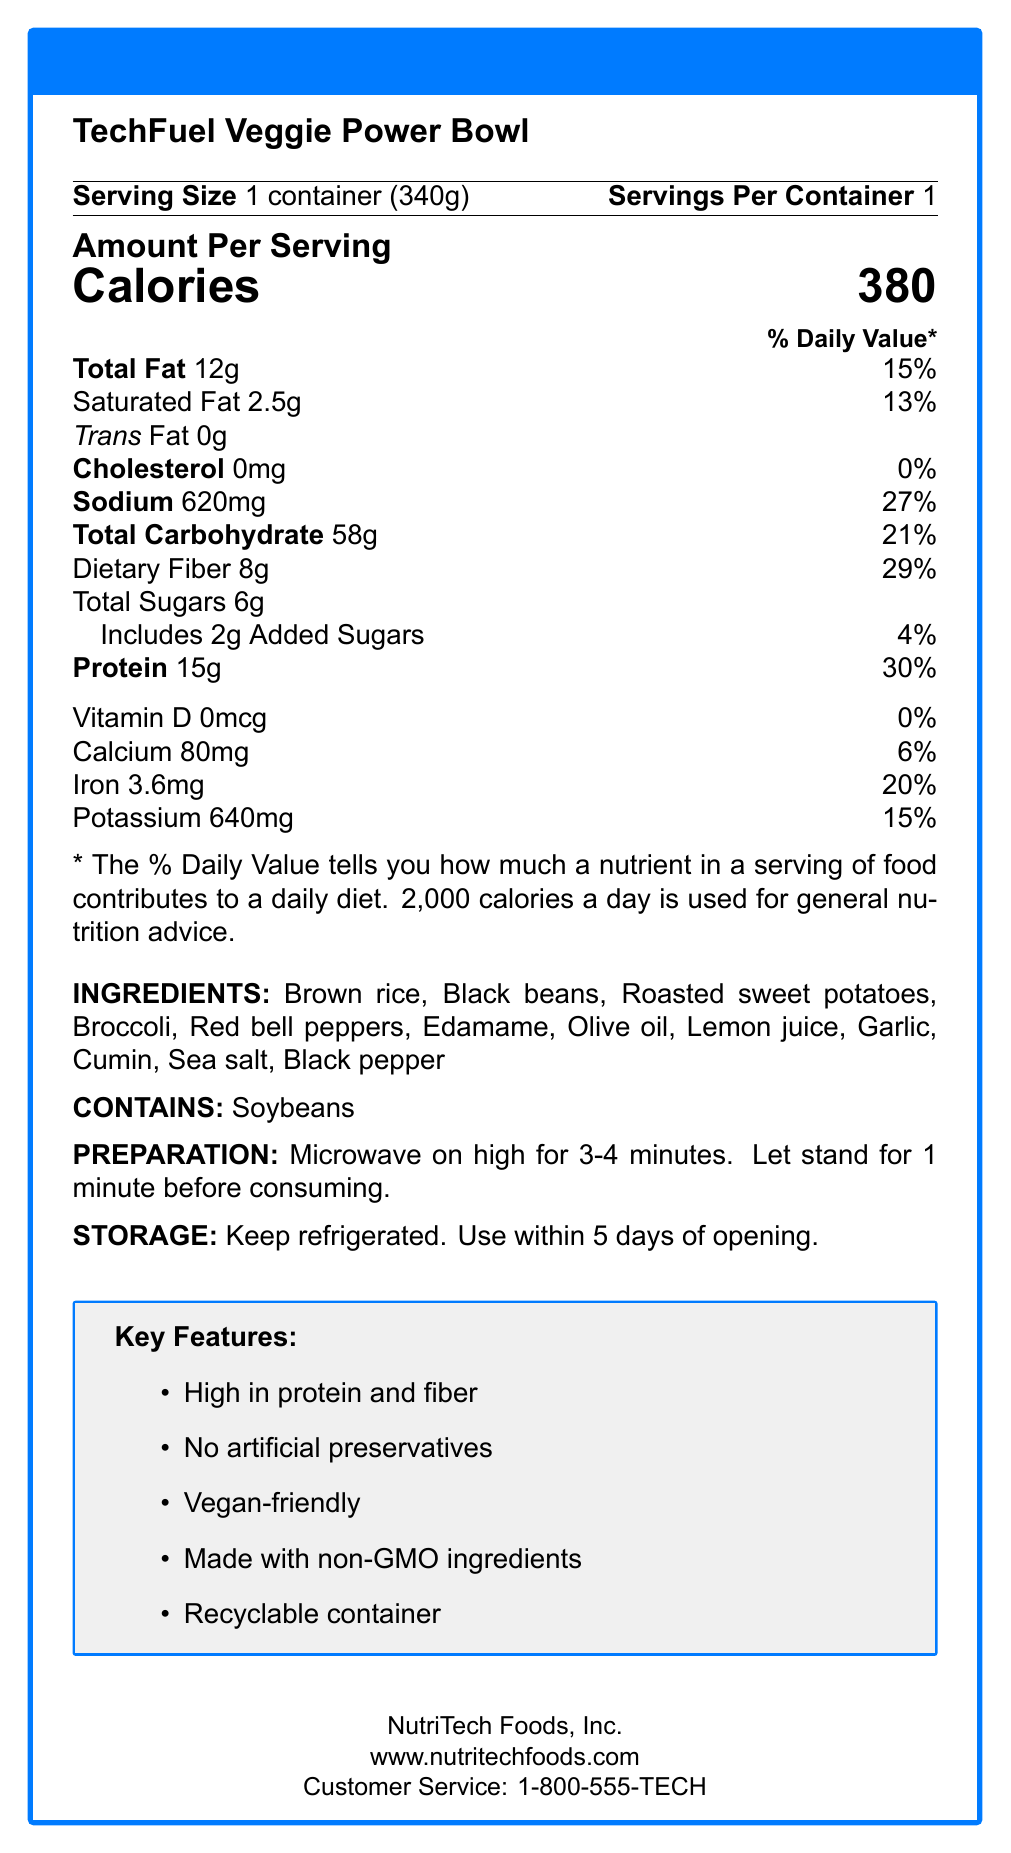what is the serving size of the TechFuel Veggie Power Bowl? The serving size is clearly stated as "1 container (340g)" near the top of the document.
Answer: 1 container (340g) how many calories are in one serving of the TechFuel Veggie Power Bowl? The calorie count for one serving is listed as 380 in the "Amount Per Serving" section.
Answer: 380 what are the main ingredients in the TechFuel Veggie Power Bowl? The ingredients are listed after the nutrition facts section under "INGREDIENTS."
Answer: Brown rice, Black beans, Roasted sweet potatoes, Broccoli, Red bell peppers, Edamame, Olive oil, Lemon juice, Garlic, Cumin, Sea salt, Black pepper how much sodium is in one serving, and what percentage of the daily value does it represent? The label shows that there is 620mg of sodium, which is 27% of the daily value.
Answer: 620mg, 27% what is the recommended preparation method for the TechFuel Veggie Power Bowl? The preparation instructions are listed under "PREPARATION."
Answer: Microwave on high for 3-4 minutes. Let stand for 1 minute before consuming. which nutrient has the highest daily value percentage in the TechFuel Veggie Power Bowl? The protein content has the highest daily value percentage of 30%, as shown in the nutrition facts.
Answer: Protein, 30% which of the following is NOT listed as a feature of the TechFuel Veggie Power Bowl? A. High in protein and fiber B. Contains artificial preservatives C. Vegan-friendly D. Made with non-GMO ingredients E. Recyclable container The nutrition label states that there are no artificial preservatives, making B the correct answer.
Answer: B what is the total carbohydrate content in one serving, and what is its percentage of the daily value? The total carbohydrate content is 58g and represents 21% of the daily value.
Answer: 58g, 21% what company manufactures the TechFuel Veggie Power Bowl? The manufacturer information at the bottom of the document states that NutriTech Foods, Inc. is the producer.
Answer: NutriTech Foods, Inc. does the TechFuel Veggie Power Bowl contain any allergens? The label indicates that it contains soybeans under the "CONTAINS" section.
Answer: Yes is the TechFuel Veggie Power Bowl considered vegan-friendly? One of the key features listed is "Vegan-friendly."
Answer: Yes summarize the key features and nutritional benefits of the TechFuel Veggie Power Bowl. This summary captures the main points of the document, including the key features, nutritional benefits, and target audience.
Answer: The TechFuel Veggie Power Bowl is a microwaveable, high-protein, high-fiber meal designed for busy tech professionals. It is vegan-friendly, contains no artificial preservatives, is made with non-GMO ingredients, and comes in a recyclable container. Each bowl has 380 calories, 15g of protein, and 8g of dietary fiber. how much added sugar is there in one serving of the TechFuel Veggie Power Bowl? The label lists 2g of added sugars under "Includes 2g Added Sugars."
Answer: 2g are there any vitamins listed with their daily value percentages? There is no daily value percentage listed for Vitamin D, which has 0mcg and a 0% daily value.
Answer: No what is the recommended storage method for the TechFuel Veggie Power Bowl? The storage instructions are listed under "STORAGE."
Answer: Keep refrigerated. Use within 5 days of opening. what is the target audience for the TechFuel Veggie Power Bowl? This information is found under the "target audience" section at the bottom of the document.
Answer: Busy tech professionals and computer science students looking for quick, nutritious meals what is the daily value percentage of calcium in the TechFuel Veggie Power Bowl? The label shows that the calcium content has a 6% daily value.
Answer: 6% does the TechFuel Veggie Power Bowl contain any animal products? While the product is labeled as vegan-friendly, the details of individual ingredients are not specified enough to determine if there are any trace animal products.
Answer: Cannot be determined how should you contact customer service for NutriTech Foods, Inc.? The customer service phone number is listed at the bottom of the document.
Answer: 1-800-555-TECH 